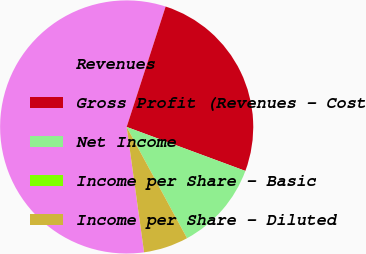Convert chart to OTSL. <chart><loc_0><loc_0><loc_500><loc_500><pie_chart><fcel>Revenues<fcel>Gross Profit (Revenues - Cost<fcel>Net Income<fcel>Income per Share - Basic<fcel>Income per Share - Diluted<nl><fcel>57.18%<fcel>25.67%<fcel>11.44%<fcel>0.0%<fcel>5.72%<nl></chart> 